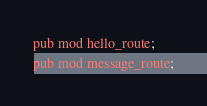Convert code to text. <code><loc_0><loc_0><loc_500><loc_500><_Rust_>pub mod hello_route;
pub mod message_route;

</code> 